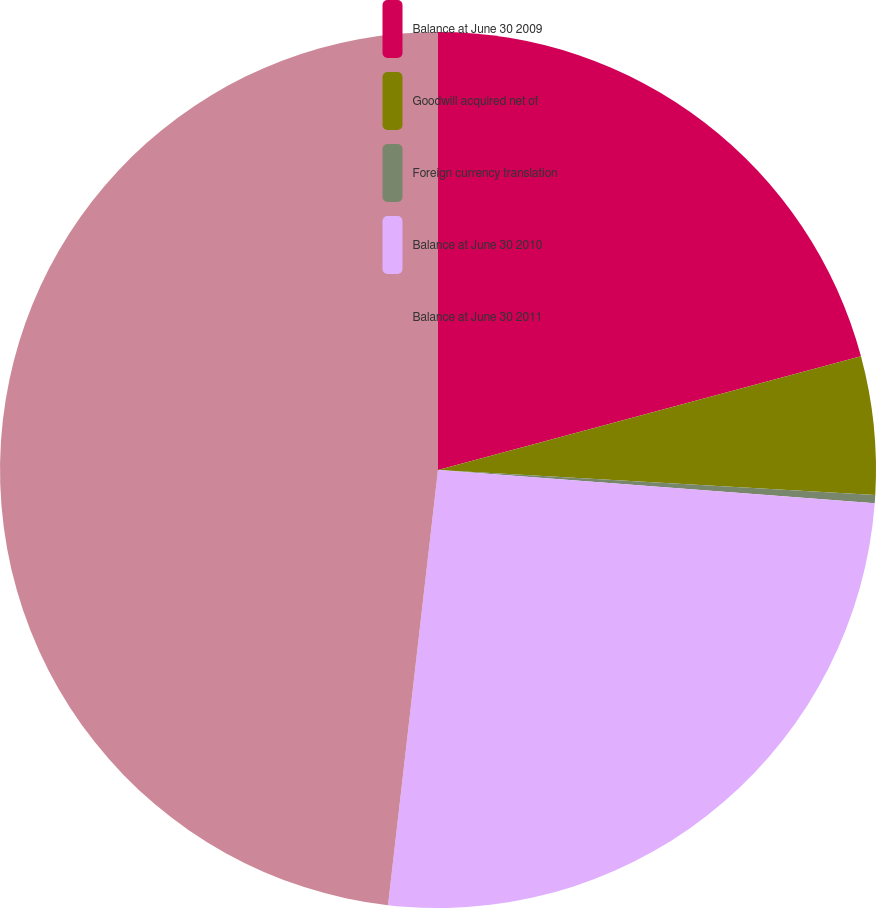Convert chart. <chart><loc_0><loc_0><loc_500><loc_500><pie_chart><fcel>Balance at June 30 2009<fcel>Goodwill acquired net of<fcel>Foreign currency translation<fcel>Balance at June 30 2010<fcel>Balance at June 30 2011<nl><fcel>20.82%<fcel>5.09%<fcel>0.3%<fcel>25.61%<fcel>48.18%<nl></chart> 